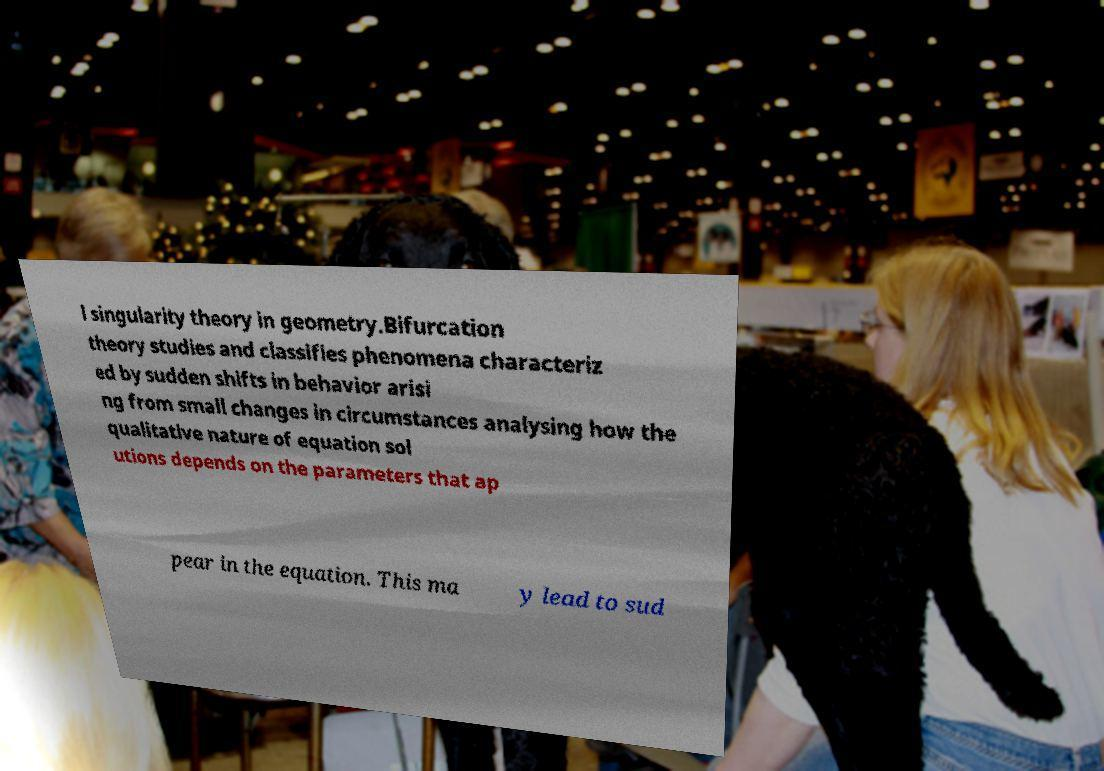Can you read and provide the text displayed in the image?This photo seems to have some interesting text. Can you extract and type it out for me? l singularity theory in geometry.Bifurcation theory studies and classifies phenomena characteriz ed by sudden shifts in behavior arisi ng from small changes in circumstances analysing how the qualitative nature of equation sol utions depends on the parameters that ap pear in the equation. This ma y lead to sud 